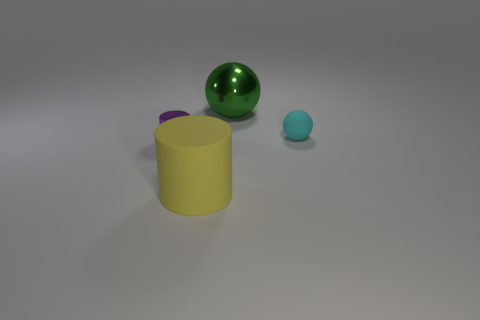Add 1 tiny metallic cylinders. How many objects exist? 5 Subtract all small gray cylinders. Subtract all cyan rubber balls. How many objects are left? 3 Add 3 metallic objects. How many metallic objects are left? 5 Add 1 small matte objects. How many small matte objects exist? 2 Subtract 1 cyan balls. How many objects are left? 3 